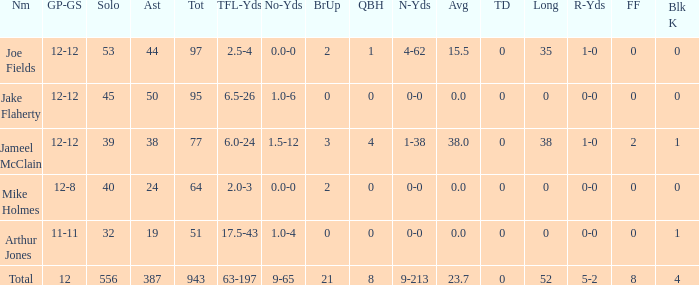How many tackle assists for the player who averages 23.7? 387.0. 